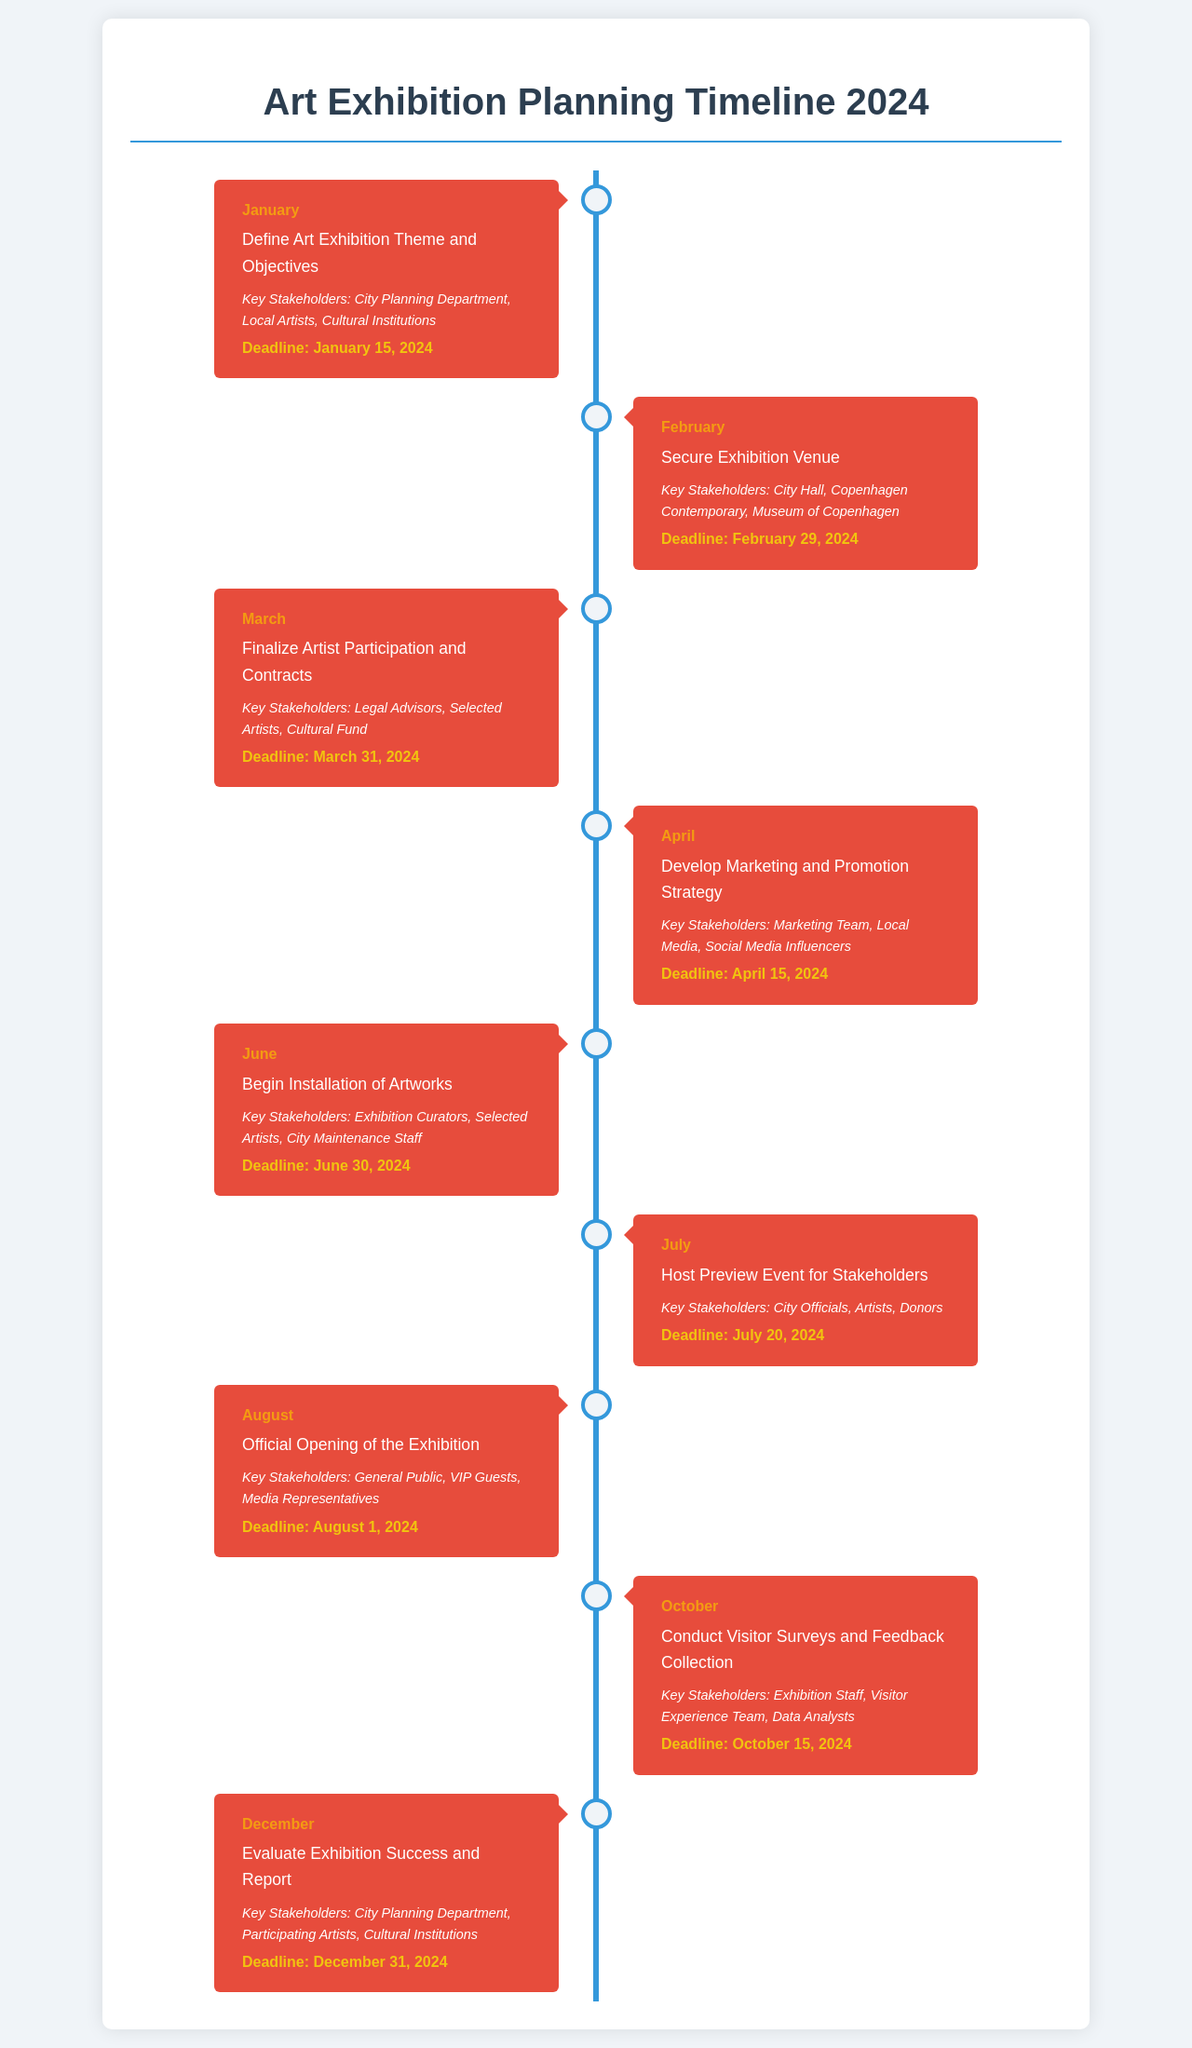What is the first milestone of the timeline? The first milestone of the timeline is defined in January, where the theme and objectives are set.
Answer: Define Art Exhibition Theme and Objectives What is the deadline for securing the exhibition venue? The deadline for securing the exhibition venue is stated clearly in the February section.
Answer: February 29, 2024 Which stakeholders are involved in developing the marketing strategy? The stakeholders involved in the marketing strategy can be found in the April part of the timeline.
Answer: Marketing Team, Local Media, Social Media Influencers When does the official opening of the exhibition take place? The official opening of the exhibition is detailed in the August segment of the document.
Answer: August 1, 2024 How many months are allocated for the installation of artworks? The period for installation begins in June and ends prior to the opening in August, making it a span of two months.
Answer: Two months What is the activity scheduled for March? The scheduled activity for March is mentioned under that month's heading in the timeline.
Answer: Finalize Artist Participation and Contracts Which key stakeholder group is responsible for visitor surveys? The group responsible for conducting visitor surveys is mentioned in the October section.
Answer: Exhibition Staff, Visitor Experience Team, Data Analysts What is the last milestone listed in the timeline? The last milestone is the evaluation of the exhibition, found in the December section.
Answer: Evaluate Exhibition Success and Report 